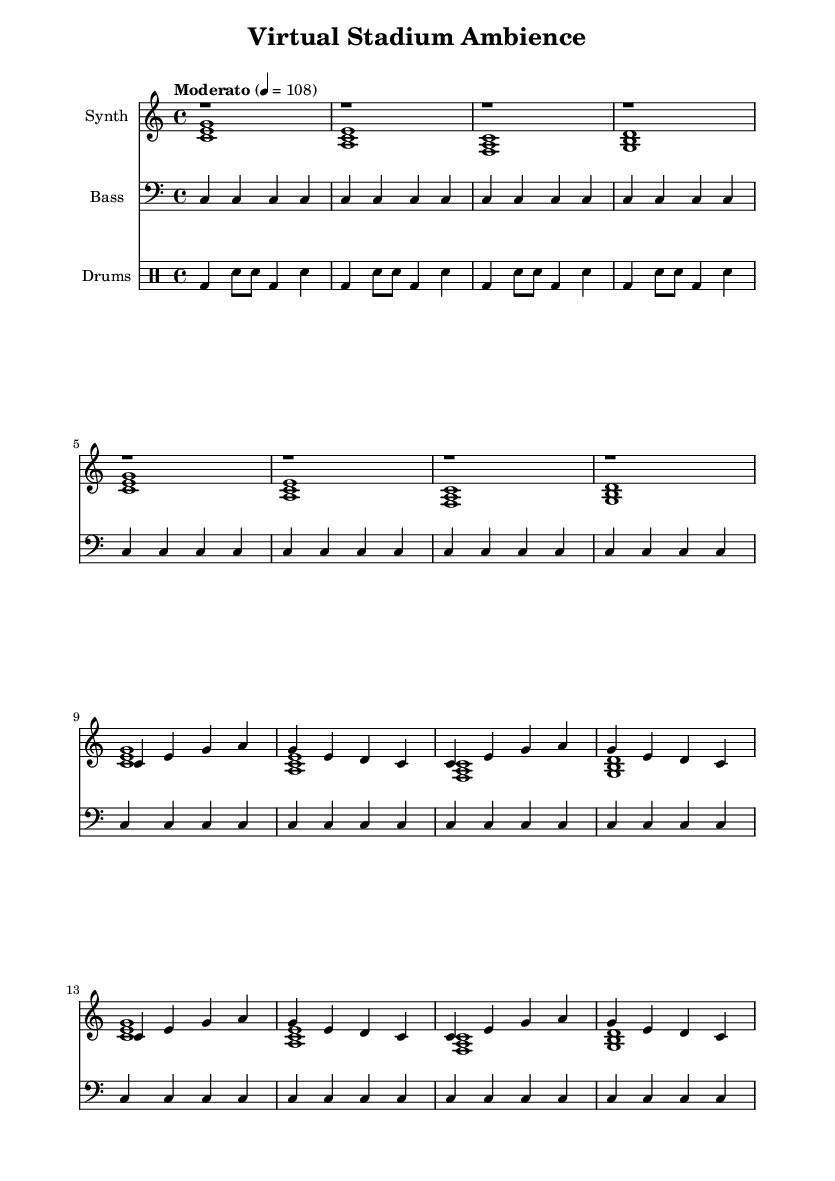What is the key signature of this music? The key signature is C major, which has no sharps or flats.
Answer: C major What is the time signature of this music? The time signature is indicated at the beginning and is 4/4, meaning there are four beats in each measure.
Answer: 4/4 What is the tempo marking for this piece? The tempo marking reads "Moderato," which specifies a moderate pace, and the metronome marking indicates 108 beats per minute.
Answer: Moderato, 108 How many repetitions does the synth melody have in the score? The synth melody section has a total of eight measures, with the same melody being repeated throughout those measures.
Answer: 8 measures What is the function of the bass in this piece? The bass plays a consistent C note throughout the piece, which serves to provide a solid foundation and support for the harmony and melody.
Answer: Foundation Which instruments are used in this piece? The piece includes a synthesizer for the melody and harmony, a bass, and a drum set for rhythm, indicating a modern, electronic style typical of experimental music.
Answer: Synth, bass, drums What pattern does the drum section follow? The drum section follows a basic alternating pattern of bass drum and snare, creating a rhythmic backing that complements the other instruments.
Answer: Bass and snare pattern 